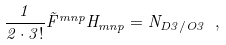Convert formula to latex. <formula><loc_0><loc_0><loc_500><loc_500>\frac { 1 } { 2 \cdot 3 ! } \tilde { F } ^ { m n p } H _ { m n p } = N _ { D 3 / O 3 } \ ,</formula> 